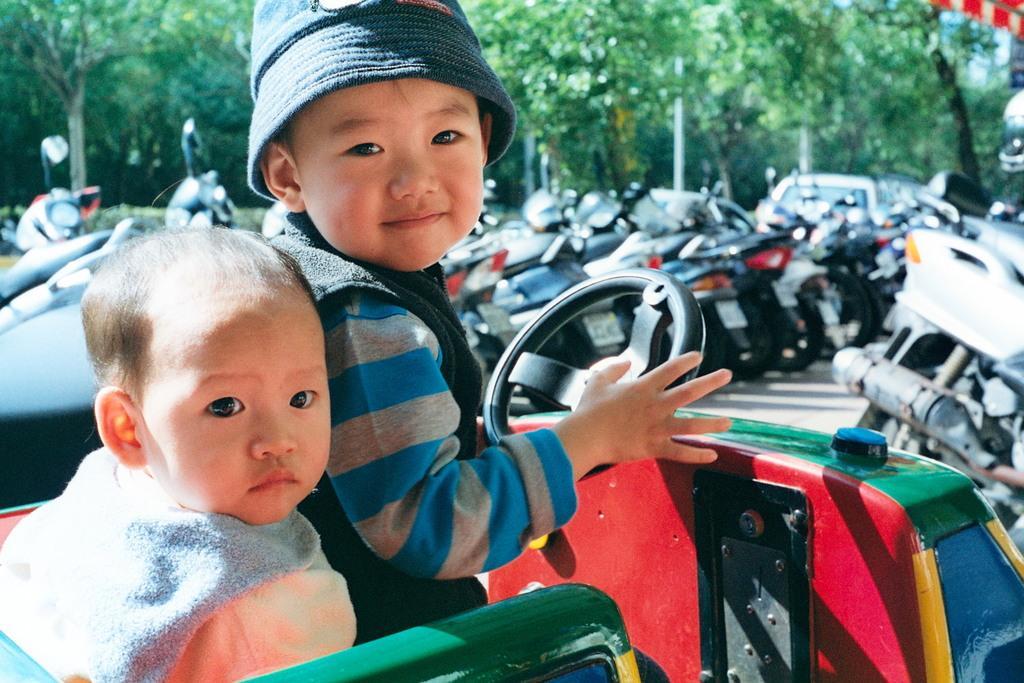Please provide a concise description of this image. In this picture there is a boy who is wearing jacket and t-shirt. Beside him there is another boy who is wearing t-shirt. Both of them are sitting on this vehicle. In the back I can see many bikes which are parked in the parking. In the background i can see many trees. Here it's a sky. 